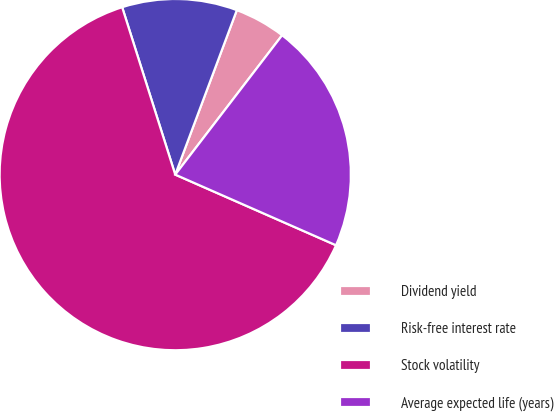<chart> <loc_0><loc_0><loc_500><loc_500><pie_chart><fcel>Dividend yield<fcel>Risk-free interest rate<fcel>Stock volatility<fcel>Average expected life (years)<nl><fcel>4.71%<fcel>10.59%<fcel>63.53%<fcel>21.18%<nl></chart> 